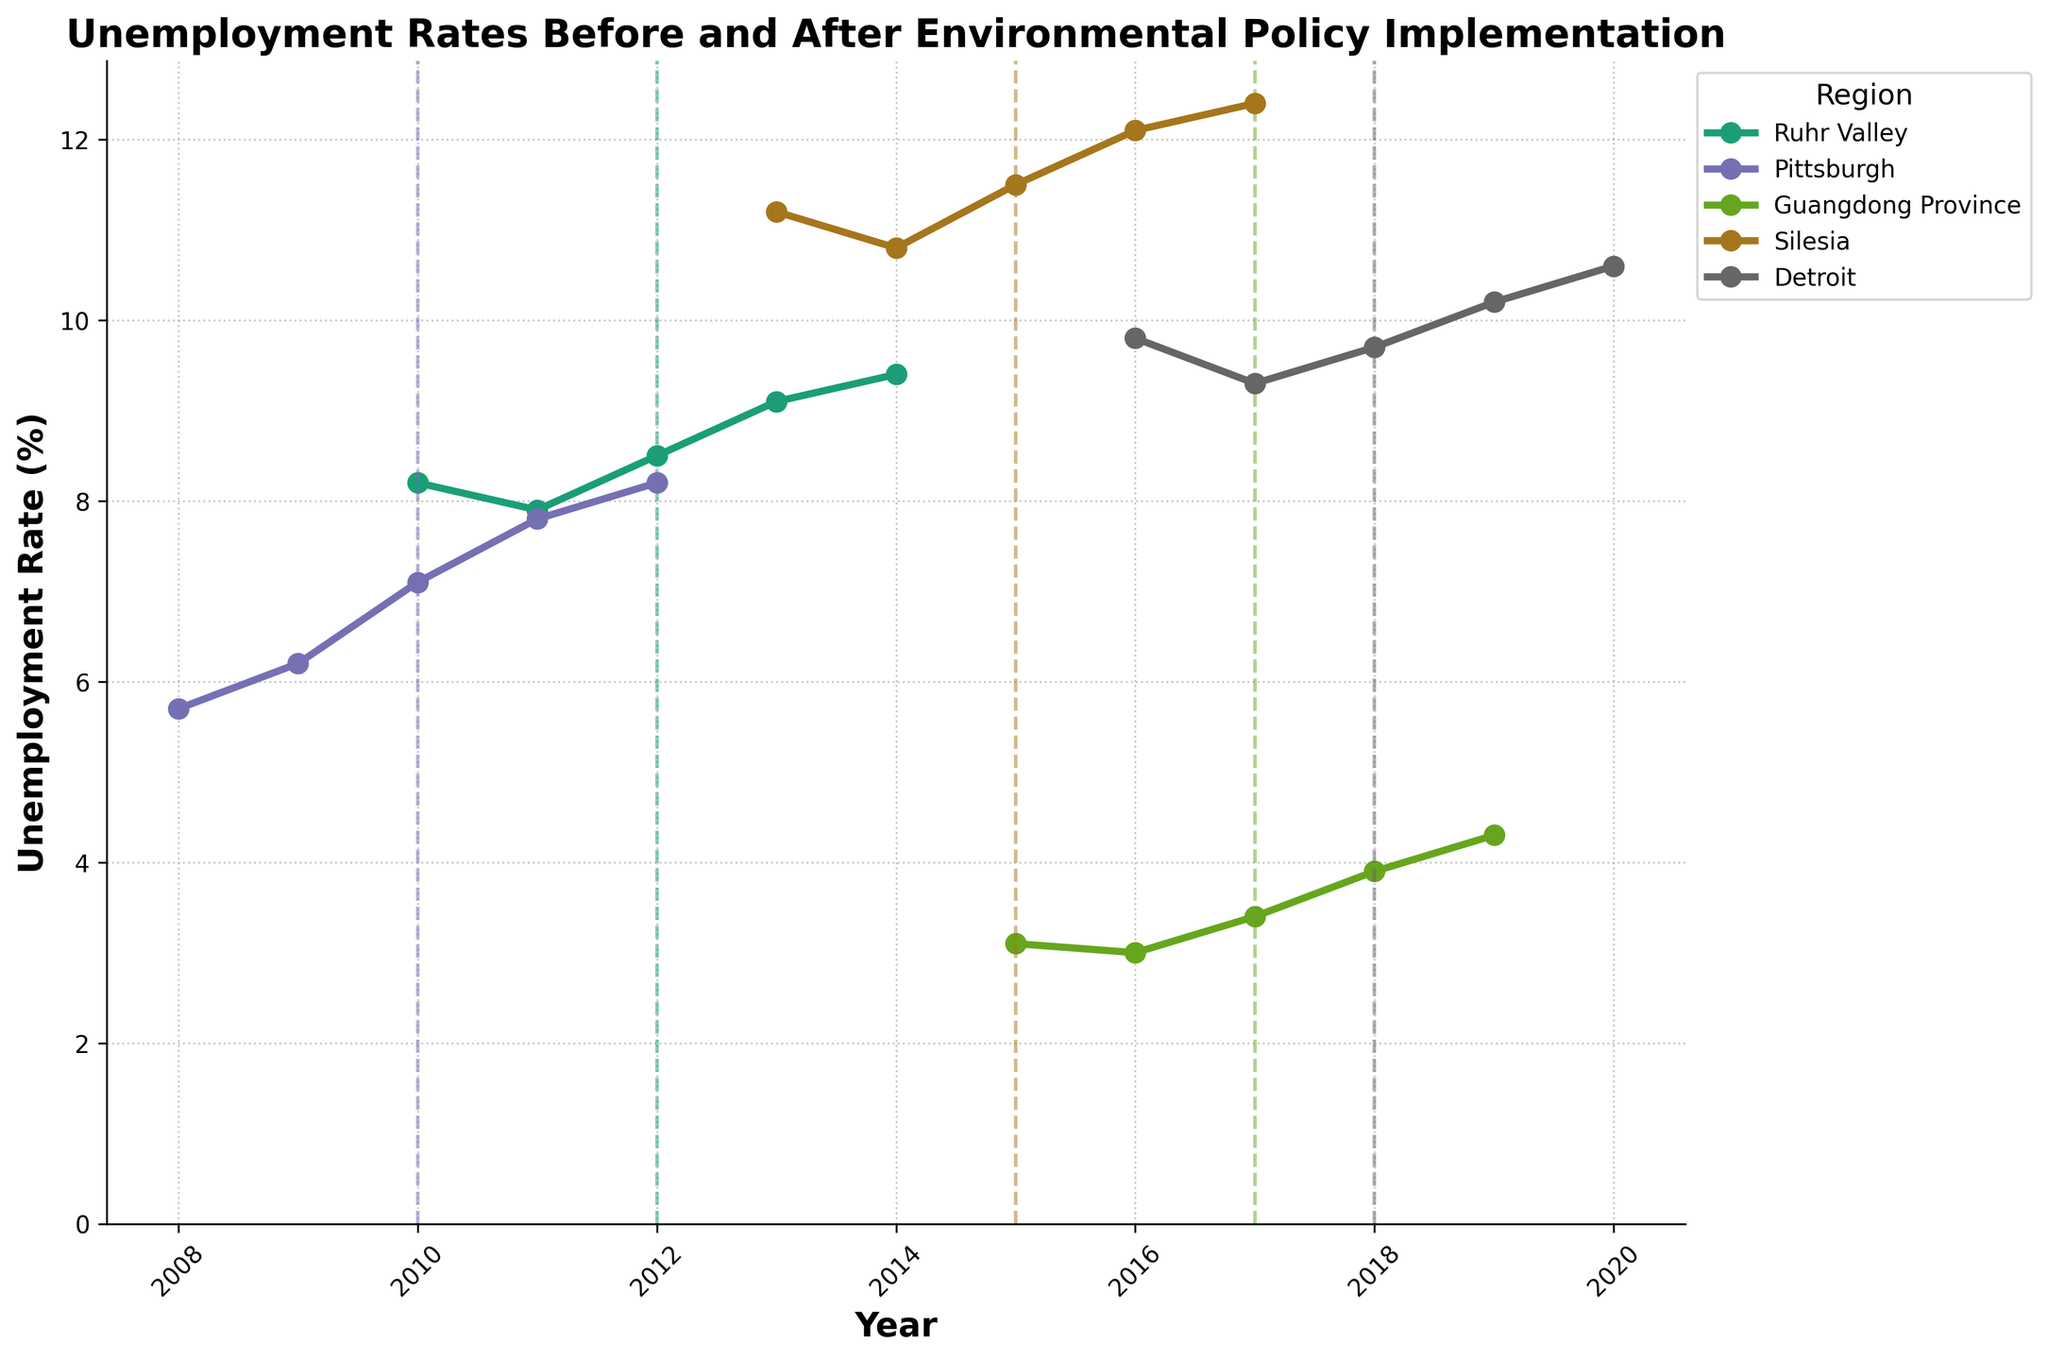What is the difference in unemployment rates in the Ruhr Valley between the year before and the year after the policy was implemented? First, identify the unemployment rates in the Ruhr Valley for 2011 (before policy) and 2013 (after policy). The unemployment rates are 7.9% (2011) and 9.1% (2013). The difference is 9.1 - 7.9 = 1.2%.
Answer: 1.2% Which region had the highest unemployment rate before the environmental policy was implemented? Check the highest unemployment rates for each region before the policy: Ruhr Valley (8.2%), Pittsburgh (6.2%), Guangdong Province (3.1%), Silesia (11.2%), and Detroit (9.8%). Silesia had the highest rate at 11.2%.
Answer: Silesia How did the unemployment rate in Pittsburgh change one year after the policy implementation? Identify the unemployment rates in Pittsburgh for the years immediately before and after the policy: 2010 (7.1%) and 2011 (7.8%). The change is 7.8 - 7.1 = 0.7%.
Answer: 0.7% Compare the trend of unemployment rates in Guangdong Province before and after the policy implementation. What do you observe? Observe the data points for Guangdong Province: Before the policy: 2015 (3.1%), 2016 (3.0%); After the policy: 2017 (3.4%), 2018 (3.9%), 2019 (4.3%). The unemployment rate was stable before the policy and showed a consistent increase after the policy implementation.
Answer: It increased after the policy Which year shows the highest unemployment rate in Silesia after the policy was implemented? Look at Silesia's data points after the policy: 2015 (11.5%), 2016 (12.1%), 2017 (12.4%). The highest rate post-policy implementation is in 2017 at 12.4%.
Answer: 2017 Did Detroit's unemployment rate ever decrease after the policy implementation? Assess the unemployment rates in Detroit after the policy: 2018 (9.7%), 2019 (10.2%), and 2020 (10.6%). The unemployment rate did not decrease post-policy implementation.
Answer: No What is the combined unemployment rate change in all regions the year after the policy was implemented? Sum the changes in unemployment rates immediately after policy implementation: Ruhr Valley (9.1 - 8.5 = 0.6), Pittsburgh (7.8 - 7.1 = 0.7), Guangdong Province (3.4 - 3.0 = 0.4), Silesia (12.1 - 11.5 = 0.6), Detroit (10.2 - 9.7 = 0.5). The total change is 0.6 + 0.7 + 0.4 + 0.6 + 0.5 = 2.8%.
Answer: 2.8% In which regions did the unemployment rate surpass 10% after the policy implementation? Check post-policy implementation rates: Ruhr Valley (9.4%), Pittsburgh (8.2%), Guangdong Province (4.3%), Silesia (12.4%), and Detroit (10.6%). Silesia and Detroit surpassed 10%.
Answer: Silesia and Detroit 